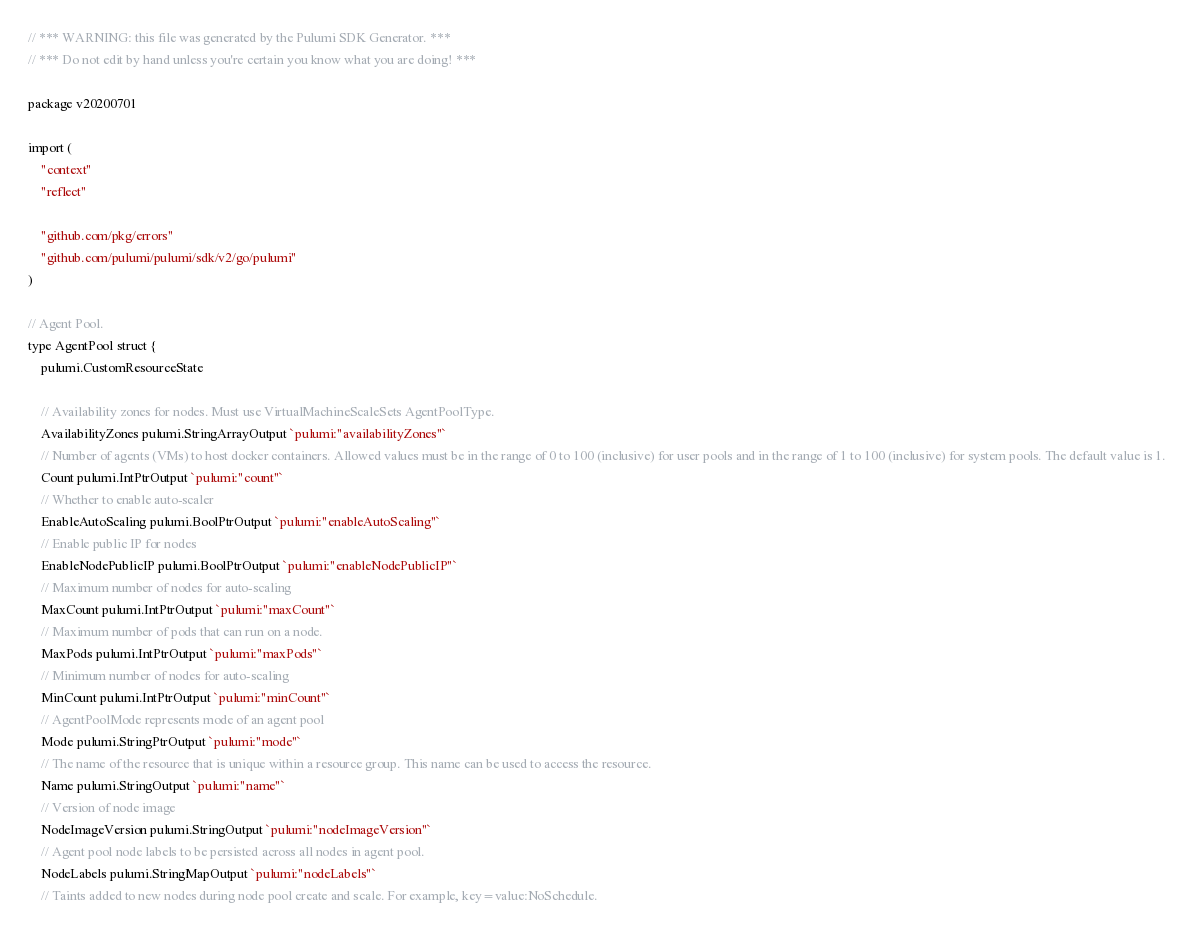<code> <loc_0><loc_0><loc_500><loc_500><_Go_>// *** WARNING: this file was generated by the Pulumi SDK Generator. ***
// *** Do not edit by hand unless you're certain you know what you are doing! ***

package v20200701

import (
	"context"
	"reflect"

	"github.com/pkg/errors"
	"github.com/pulumi/pulumi/sdk/v2/go/pulumi"
)

// Agent Pool.
type AgentPool struct {
	pulumi.CustomResourceState

	// Availability zones for nodes. Must use VirtualMachineScaleSets AgentPoolType.
	AvailabilityZones pulumi.StringArrayOutput `pulumi:"availabilityZones"`
	// Number of agents (VMs) to host docker containers. Allowed values must be in the range of 0 to 100 (inclusive) for user pools and in the range of 1 to 100 (inclusive) for system pools. The default value is 1.
	Count pulumi.IntPtrOutput `pulumi:"count"`
	// Whether to enable auto-scaler
	EnableAutoScaling pulumi.BoolPtrOutput `pulumi:"enableAutoScaling"`
	// Enable public IP for nodes
	EnableNodePublicIP pulumi.BoolPtrOutput `pulumi:"enableNodePublicIP"`
	// Maximum number of nodes for auto-scaling
	MaxCount pulumi.IntPtrOutput `pulumi:"maxCount"`
	// Maximum number of pods that can run on a node.
	MaxPods pulumi.IntPtrOutput `pulumi:"maxPods"`
	// Minimum number of nodes for auto-scaling
	MinCount pulumi.IntPtrOutput `pulumi:"minCount"`
	// AgentPoolMode represents mode of an agent pool
	Mode pulumi.StringPtrOutput `pulumi:"mode"`
	// The name of the resource that is unique within a resource group. This name can be used to access the resource.
	Name pulumi.StringOutput `pulumi:"name"`
	// Version of node image
	NodeImageVersion pulumi.StringOutput `pulumi:"nodeImageVersion"`
	// Agent pool node labels to be persisted across all nodes in agent pool.
	NodeLabels pulumi.StringMapOutput `pulumi:"nodeLabels"`
	// Taints added to new nodes during node pool create and scale. For example, key=value:NoSchedule.</code> 